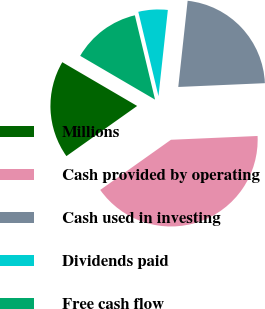Convert chart to OTSL. <chart><loc_0><loc_0><loc_500><loc_500><pie_chart><fcel>Millions<fcel>Cash provided by operating<fcel>Cash used in investing<fcel>Dividends paid<fcel>Free cash flow<nl><fcel>18.24%<fcel>40.88%<fcel>22.58%<fcel>5.46%<fcel>12.84%<nl></chart> 